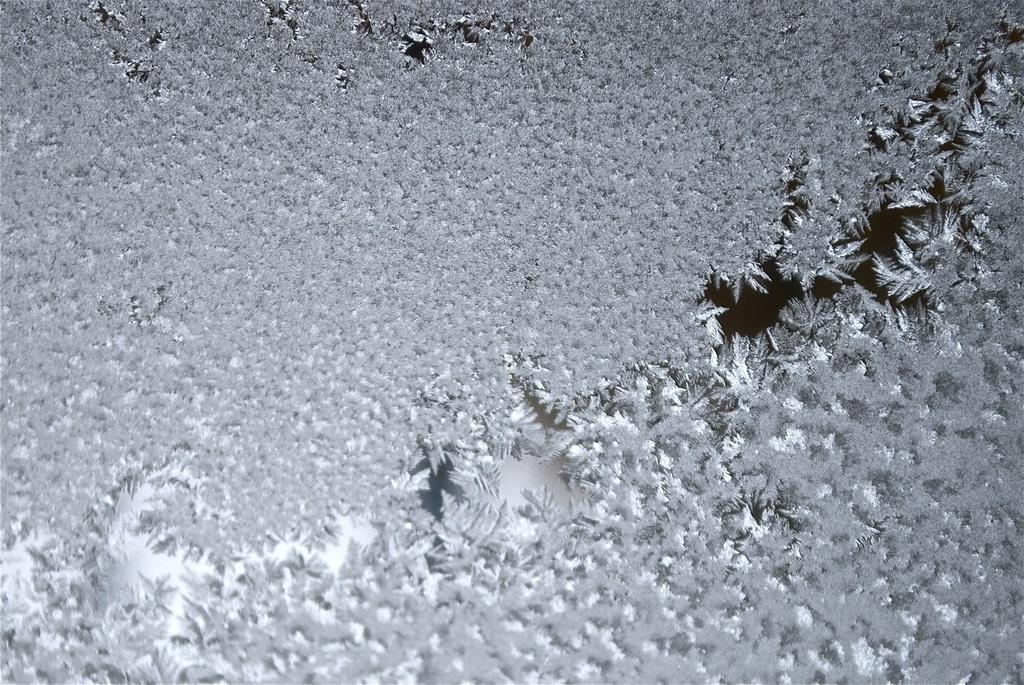What type of image is present in the picture? The image contains a graphical image. What color is the graphical image? The graphical image is in grey color. What can be seen in the water in the image? There are leaves in the water in the image. What type of soup is being served to the visitor in the image? There is no visitor or soup present in the image; it features a graphical image with grey color and leaves in the water. 